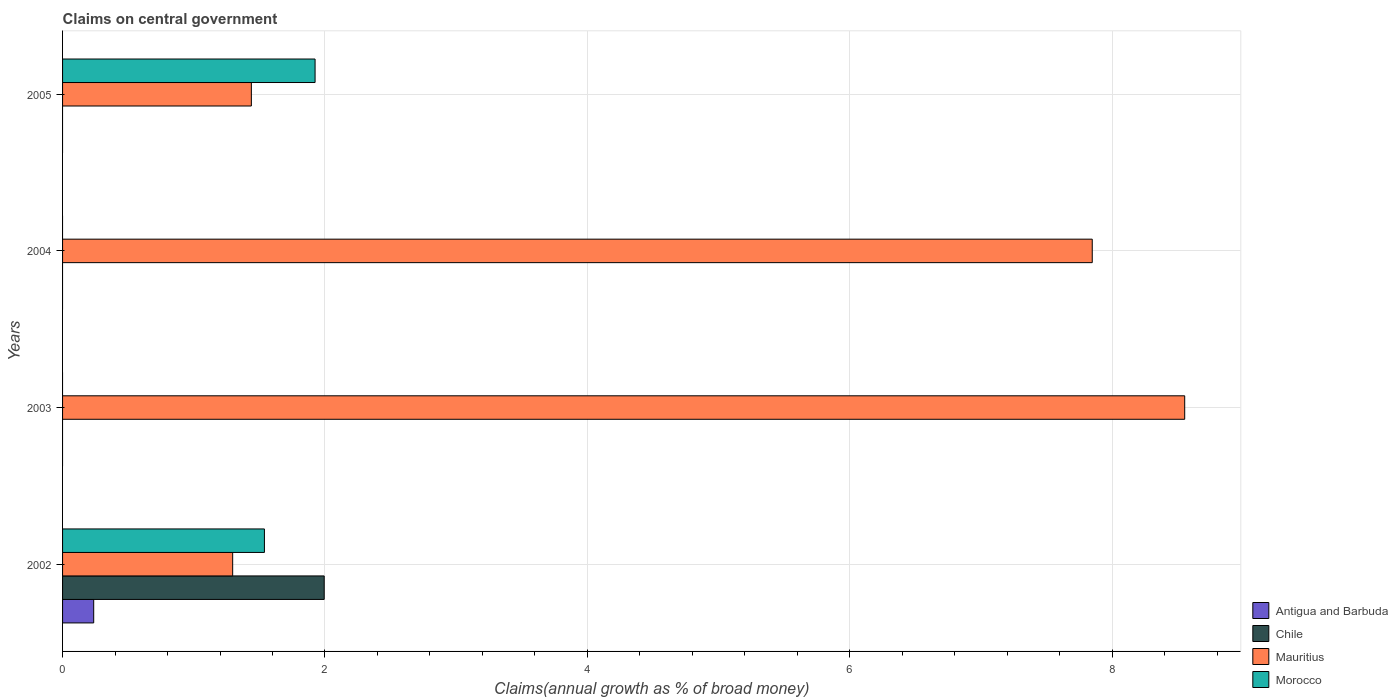How many different coloured bars are there?
Offer a terse response. 4. Are the number of bars on each tick of the Y-axis equal?
Your answer should be very brief. No. How many bars are there on the 1st tick from the top?
Your answer should be compact. 2. What is the label of the 4th group of bars from the top?
Make the answer very short. 2002. What is the percentage of broad money claimed on centeral government in Morocco in 2002?
Your response must be concise. 1.54. Across all years, what is the maximum percentage of broad money claimed on centeral government in Antigua and Barbuda?
Provide a succinct answer. 0.24. What is the total percentage of broad money claimed on centeral government in Mauritius in the graph?
Your response must be concise. 19.14. What is the difference between the percentage of broad money claimed on centeral government in Mauritius in 2002 and that in 2004?
Give a very brief answer. -6.55. What is the difference between the percentage of broad money claimed on centeral government in Chile in 2004 and the percentage of broad money claimed on centeral government in Antigua and Barbuda in 2002?
Your answer should be very brief. -0.24. What is the average percentage of broad money claimed on centeral government in Morocco per year?
Your answer should be compact. 0.87. In the year 2002, what is the difference between the percentage of broad money claimed on centeral government in Chile and percentage of broad money claimed on centeral government in Antigua and Barbuda?
Your answer should be very brief. 1.76. What is the ratio of the percentage of broad money claimed on centeral government in Mauritius in 2004 to that in 2005?
Your answer should be compact. 5.45. Is the percentage of broad money claimed on centeral government in Mauritius in 2002 less than that in 2004?
Offer a very short reply. Yes. What is the difference between the highest and the second highest percentage of broad money claimed on centeral government in Mauritius?
Offer a terse response. 0.7. What is the difference between the highest and the lowest percentage of broad money claimed on centeral government in Antigua and Barbuda?
Offer a terse response. 0.24. Is it the case that in every year, the sum of the percentage of broad money claimed on centeral government in Morocco and percentage of broad money claimed on centeral government in Chile is greater than the percentage of broad money claimed on centeral government in Mauritius?
Make the answer very short. No. How many bars are there?
Provide a short and direct response. 8. Are all the bars in the graph horizontal?
Ensure brevity in your answer.  Yes. Does the graph contain any zero values?
Give a very brief answer. Yes. Where does the legend appear in the graph?
Provide a succinct answer. Bottom right. How are the legend labels stacked?
Your answer should be compact. Vertical. What is the title of the graph?
Your response must be concise. Claims on central government. What is the label or title of the X-axis?
Make the answer very short. Claims(annual growth as % of broad money). What is the Claims(annual growth as % of broad money) in Antigua and Barbuda in 2002?
Give a very brief answer. 0.24. What is the Claims(annual growth as % of broad money) of Chile in 2002?
Provide a succinct answer. 1.99. What is the Claims(annual growth as % of broad money) of Mauritius in 2002?
Provide a short and direct response. 1.3. What is the Claims(annual growth as % of broad money) in Morocco in 2002?
Offer a very short reply. 1.54. What is the Claims(annual growth as % of broad money) of Chile in 2003?
Provide a short and direct response. 0. What is the Claims(annual growth as % of broad money) in Mauritius in 2003?
Give a very brief answer. 8.55. What is the Claims(annual growth as % of broad money) of Chile in 2004?
Your response must be concise. 0. What is the Claims(annual growth as % of broad money) of Mauritius in 2004?
Provide a short and direct response. 7.85. What is the Claims(annual growth as % of broad money) in Antigua and Barbuda in 2005?
Offer a very short reply. 0. What is the Claims(annual growth as % of broad money) in Mauritius in 2005?
Your response must be concise. 1.44. What is the Claims(annual growth as % of broad money) in Morocco in 2005?
Provide a succinct answer. 1.92. Across all years, what is the maximum Claims(annual growth as % of broad money) in Antigua and Barbuda?
Your answer should be very brief. 0.24. Across all years, what is the maximum Claims(annual growth as % of broad money) of Chile?
Make the answer very short. 1.99. Across all years, what is the maximum Claims(annual growth as % of broad money) of Mauritius?
Offer a very short reply. 8.55. Across all years, what is the maximum Claims(annual growth as % of broad money) in Morocco?
Ensure brevity in your answer.  1.92. Across all years, what is the minimum Claims(annual growth as % of broad money) in Mauritius?
Offer a very short reply. 1.3. Across all years, what is the minimum Claims(annual growth as % of broad money) of Morocco?
Ensure brevity in your answer.  0. What is the total Claims(annual growth as % of broad money) of Antigua and Barbuda in the graph?
Provide a succinct answer. 0.24. What is the total Claims(annual growth as % of broad money) in Chile in the graph?
Ensure brevity in your answer.  1.99. What is the total Claims(annual growth as % of broad money) of Mauritius in the graph?
Provide a succinct answer. 19.14. What is the total Claims(annual growth as % of broad money) in Morocco in the graph?
Make the answer very short. 3.46. What is the difference between the Claims(annual growth as % of broad money) in Mauritius in 2002 and that in 2003?
Offer a very short reply. -7.26. What is the difference between the Claims(annual growth as % of broad money) in Mauritius in 2002 and that in 2004?
Give a very brief answer. -6.55. What is the difference between the Claims(annual growth as % of broad money) of Mauritius in 2002 and that in 2005?
Your answer should be very brief. -0.14. What is the difference between the Claims(annual growth as % of broad money) in Morocco in 2002 and that in 2005?
Your response must be concise. -0.39. What is the difference between the Claims(annual growth as % of broad money) in Mauritius in 2003 and that in 2004?
Give a very brief answer. 0.7. What is the difference between the Claims(annual growth as % of broad money) of Mauritius in 2003 and that in 2005?
Give a very brief answer. 7.11. What is the difference between the Claims(annual growth as % of broad money) of Mauritius in 2004 and that in 2005?
Ensure brevity in your answer.  6.41. What is the difference between the Claims(annual growth as % of broad money) of Antigua and Barbuda in 2002 and the Claims(annual growth as % of broad money) of Mauritius in 2003?
Offer a terse response. -8.32. What is the difference between the Claims(annual growth as % of broad money) of Chile in 2002 and the Claims(annual growth as % of broad money) of Mauritius in 2003?
Your answer should be compact. -6.56. What is the difference between the Claims(annual growth as % of broad money) of Antigua and Barbuda in 2002 and the Claims(annual growth as % of broad money) of Mauritius in 2004?
Your answer should be compact. -7.61. What is the difference between the Claims(annual growth as % of broad money) in Chile in 2002 and the Claims(annual growth as % of broad money) in Mauritius in 2004?
Make the answer very short. -5.85. What is the difference between the Claims(annual growth as % of broad money) in Antigua and Barbuda in 2002 and the Claims(annual growth as % of broad money) in Mauritius in 2005?
Your answer should be very brief. -1.2. What is the difference between the Claims(annual growth as % of broad money) of Antigua and Barbuda in 2002 and the Claims(annual growth as % of broad money) of Morocco in 2005?
Give a very brief answer. -1.69. What is the difference between the Claims(annual growth as % of broad money) in Chile in 2002 and the Claims(annual growth as % of broad money) in Mauritius in 2005?
Offer a very short reply. 0.56. What is the difference between the Claims(annual growth as % of broad money) of Chile in 2002 and the Claims(annual growth as % of broad money) of Morocco in 2005?
Provide a short and direct response. 0.07. What is the difference between the Claims(annual growth as % of broad money) in Mauritius in 2002 and the Claims(annual growth as % of broad money) in Morocco in 2005?
Give a very brief answer. -0.63. What is the difference between the Claims(annual growth as % of broad money) of Mauritius in 2003 and the Claims(annual growth as % of broad money) of Morocco in 2005?
Ensure brevity in your answer.  6.63. What is the difference between the Claims(annual growth as % of broad money) in Mauritius in 2004 and the Claims(annual growth as % of broad money) in Morocco in 2005?
Give a very brief answer. 5.92. What is the average Claims(annual growth as % of broad money) of Antigua and Barbuda per year?
Your answer should be compact. 0.06. What is the average Claims(annual growth as % of broad money) in Chile per year?
Your response must be concise. 0.5. What is the average Claims(annual growth as % of broad money) of Mauritius per year?
Provide a short and direct response. 4.78. What is the average Claims(annual growth as % of broad money) of Morocco per year?
Keep it short and to the point. 0.87. In the year 2002, what is the difference between the Claims(annual growth as % of broad money) in Antigua and Barbuda and Claims(annual growth as % of broad money) in Chile?
Your answer should be compact. -1.76. In the year 2002, what is the difference between the Claims(annual growth as % of broad money) in Antigua and Barbuda and Claims(annual growth as % of broad money) in Mauritius?
Your answer should be very brief. -1.06. In the year 2002, what is the difference between the Claims(annual growth as % of broad money) of Antigua and Barbuda and Claims(annual growth as % of broad money) of Morocco?
Provide a succinct answer. -1.3. In the year 2002, what is the difference between the Claims(annual growth as % of broad money) in Chile and Claims(annual growth as % of broad money) in Mauritius?
Offer a terse response. 0.7. In the year 2002, what is the difference between the Claims(annual growth as % of broad money) in Chile and Claims(annual growth as % of broad money) in Morocco?
Give a very brief answer. 0.46. In the year 2002, what is the difference between the Claims(annual growth as % of broad money) in Mauritius and Claims(annual growth as % of broad money) in Morocco?
Offer a terse response. -0.24. In the year 2005, what is the difference between the Claims(annual growth as % of broad money) of Mauritius and Claims(annual growth as % of broad money) of Morocco?
Your response must be concise. -0.49. What is the ratio of the Claims(annual growth as % of broad money) in Mauritius in 2002 to that in 2003?
Your answer should be very brief. 0.15. What is the ratio of the Claims(annual growth as % of broad money) in Mauritius in 2002 to that in 2004?
Offer a very short reply. 0.17. What is the ratio of the Claims(annual growth as % of broad money) in Mauritius in 2002 to that in 2005?
Offer a terse response. 0.9. What is the ratio of the Claims(annual growth as % of broad money) in Morocco in 2002 to that in 2005?
Offer a very short reply. 0.8. What is the ratio of the Claims(annual growth as % of broad money) in Mauritius in 2003 to that in 2004?
Your answer should be very brief. 1.09. What is the ratio of the Claims(annual growth as % of broad money) of Mauritius in 2003 to that in 2005?
Provide a short and direct response. 5.94. What is the ratio of the Claims(annual growth as % of broad money) in Mauritius in 2004 to that in 2005?
Your response must be concise. 5.45. What is the difference between the highest and the second highest Claims(annual growth as % of broad money) of Mauritius?
Ensure brevity in your answer.  0.7. What is the difference between the highest and the lowest Claims(annual growth as % of broad money) in Antigua and Barbuda?
Your response must be concise. 0.24. What is the difference between the highest and the lowest Claims(annual growth as % of broad money) of Chile?
Offer a very short reply. 1.99. What is the difference between the highest and the lowest Claims(annual growth as % of broad money) in Mauritius?
Make the answer very short. 7.26. What is the difference between the highest and the lowest Claims(annual growth as % of broad money) of Morocco?
Give a very brief answer. 1.92. 